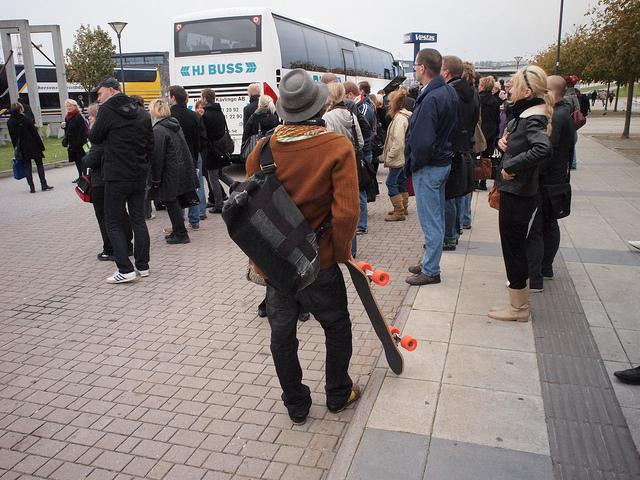What kind of bus is the white vehicle? passenger bus 